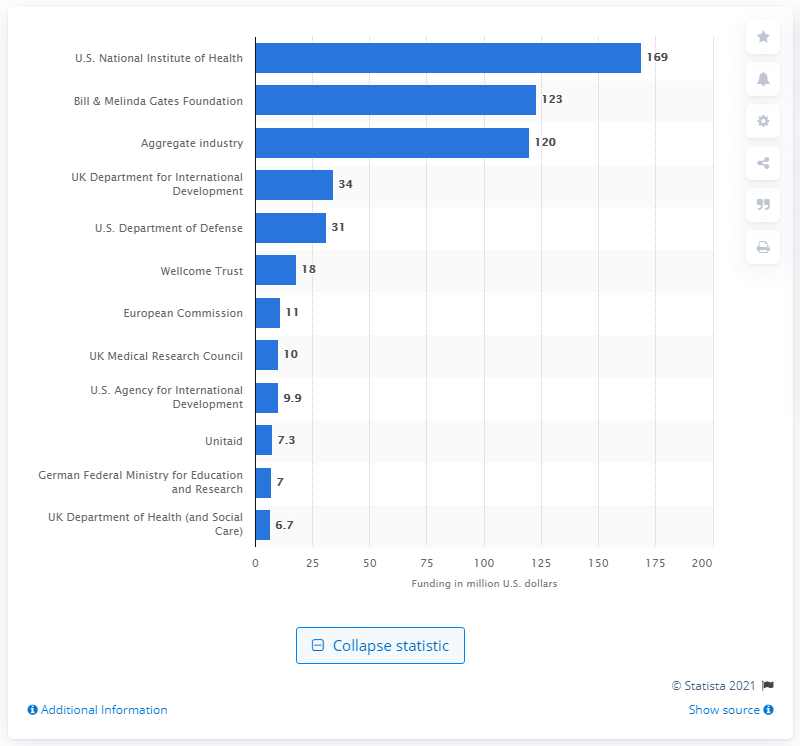Point out several critical features in this image. The National Institutes of Health spent $169 million on malaria research and development in 2019. 